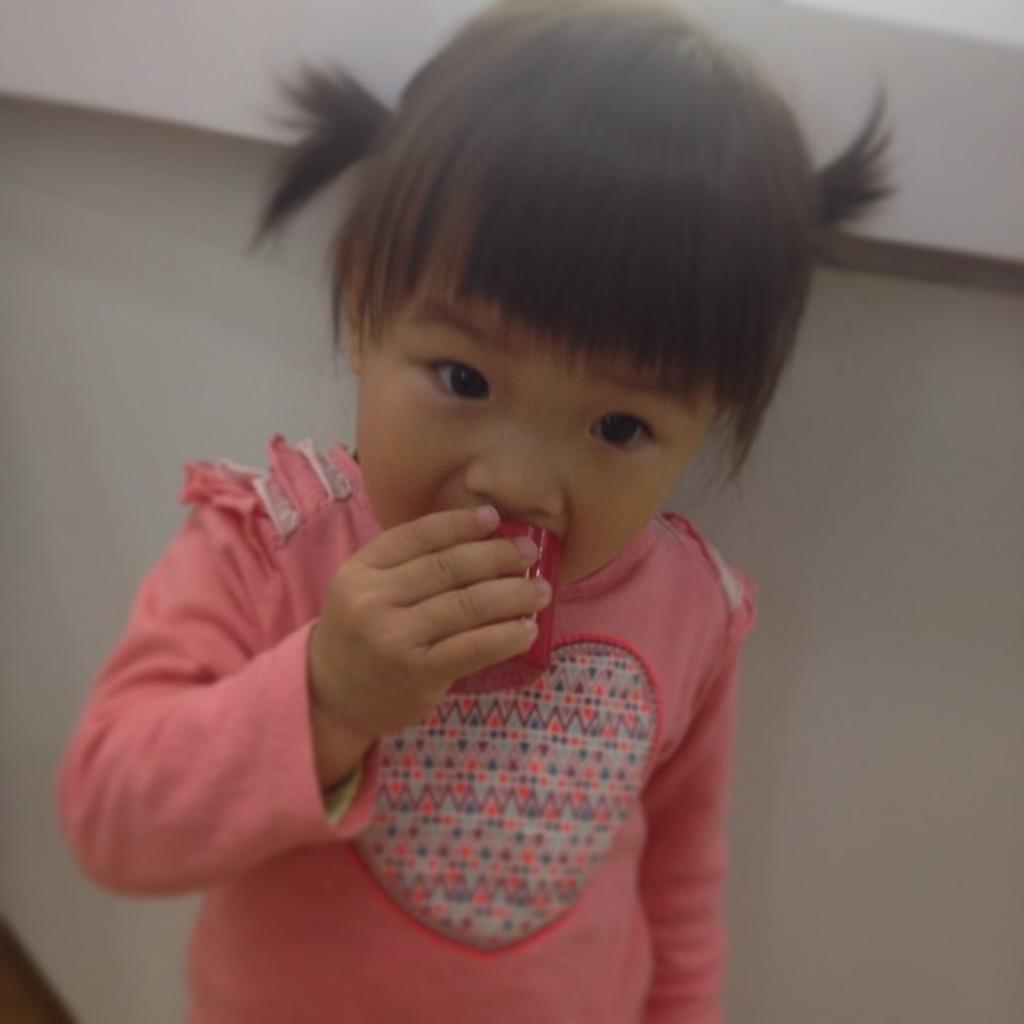Can you describe this image briefly? There is a cute baby girl standing in front of a table,she is wearing pink dress and she is putting some object into her mouth. 